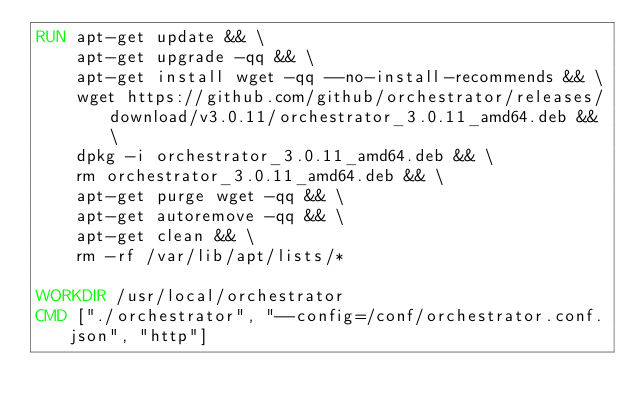Convert code to text. <code><loc_0><loc_0><loc_500><loc_500><_Dockerfile_>RUN apt-get update && \
    apt-get upgrade -qq && \
    apt-get install wget -qq --no-install-recommends && \
    wget https://github.com/github/orchestrator/releases/download/v3.0.11/orchestrator_3.0.11_amd64.deb && \
    dpkg -i orchestrator_3.0.11_amd64.deb && \
    rm orchestrator_3.0.11_amd64.deb && \
    apt-get purge wget -qq && \
    apt-get autoremove -qq && \
    apt-get clean && \
    rm -rf /var/lib/apt/lists/*

WORKDIR /usr/local/orchestrator
CMD ["./orchestrator", "--config=/conf/orchestrator.conf.json", "http"]
</code> 